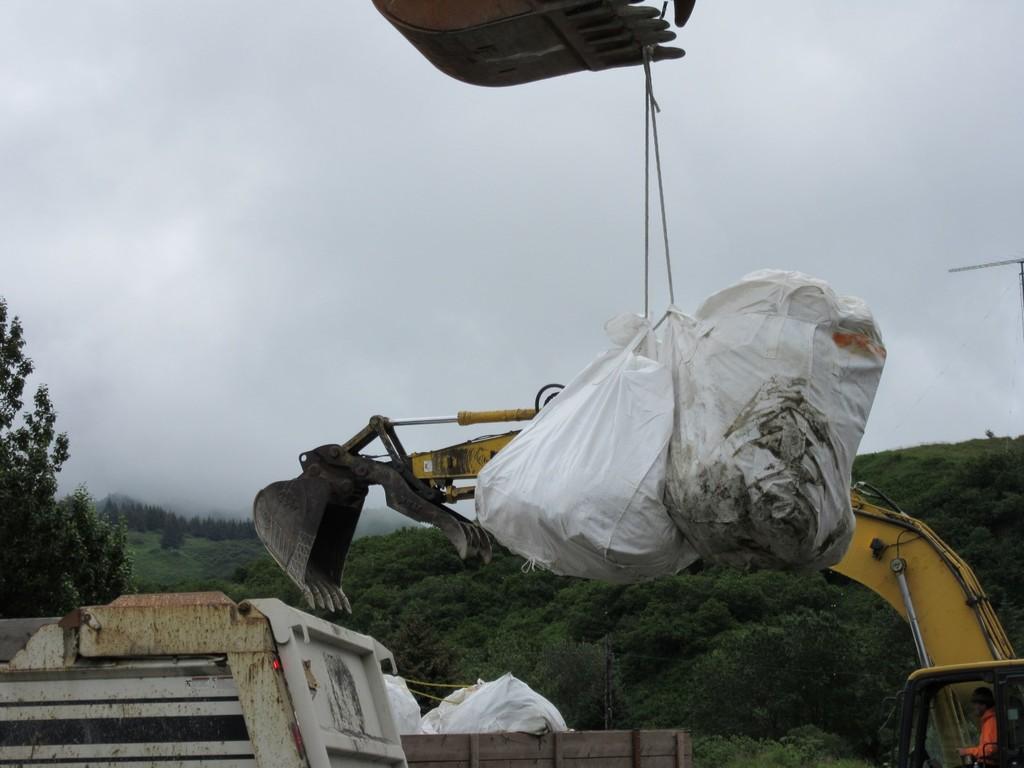Describe this image in one or two sentences. In the image we can see a vehicle, plastic bag, rope, trees, mountain and a cloudy sky. We can even see there is a person wearing clothes. 